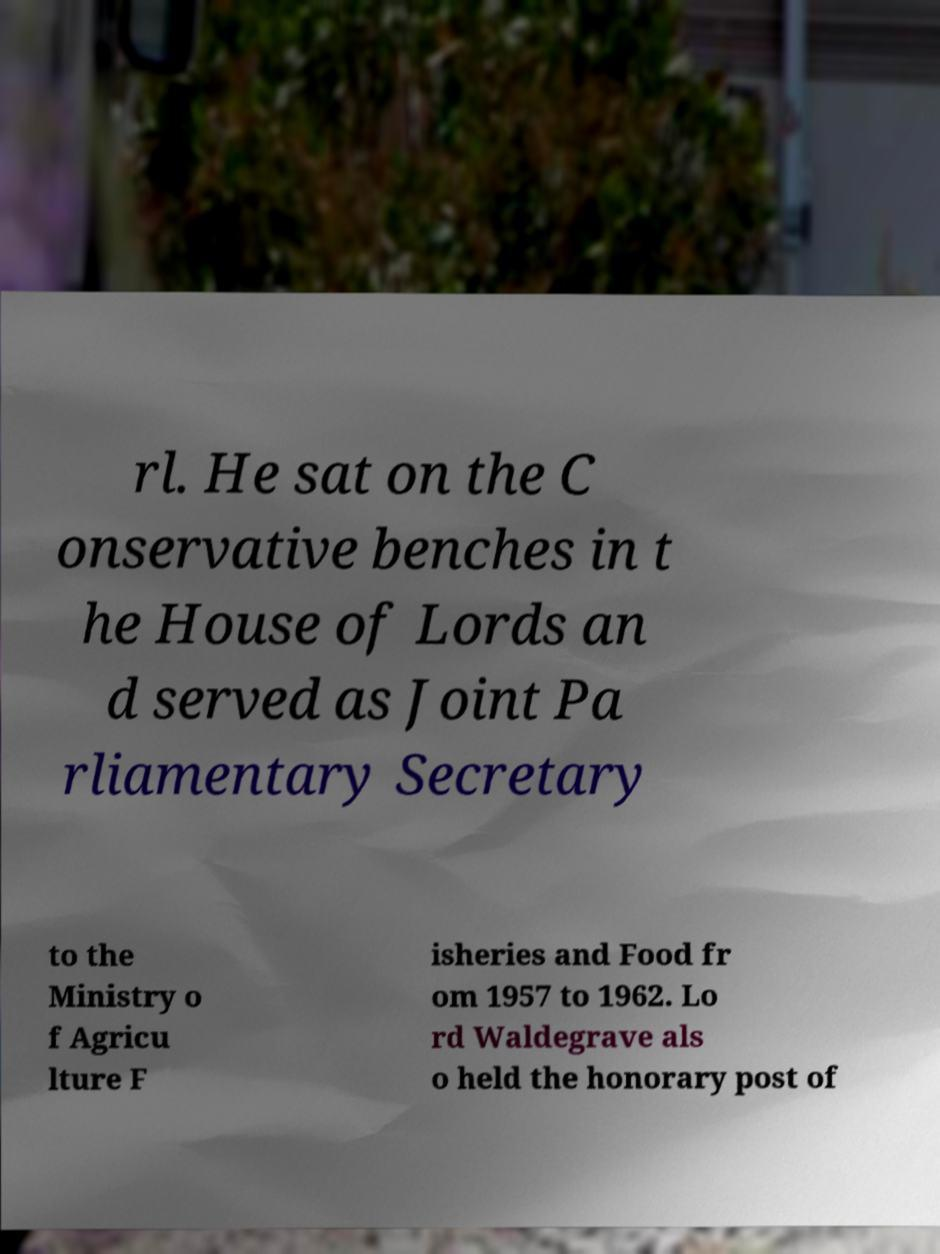What messages or text are displayed in this image? I need them in a readable, typed format. rl. He sat on the C onservative benches in t he House of Lords an d served as Joint Pa rliamentary Secretary to the Ministry o f Agricu lture F isheries and Food fr om 1957 to 1962. Lo rd Waldegrave als o held the honorary post of 